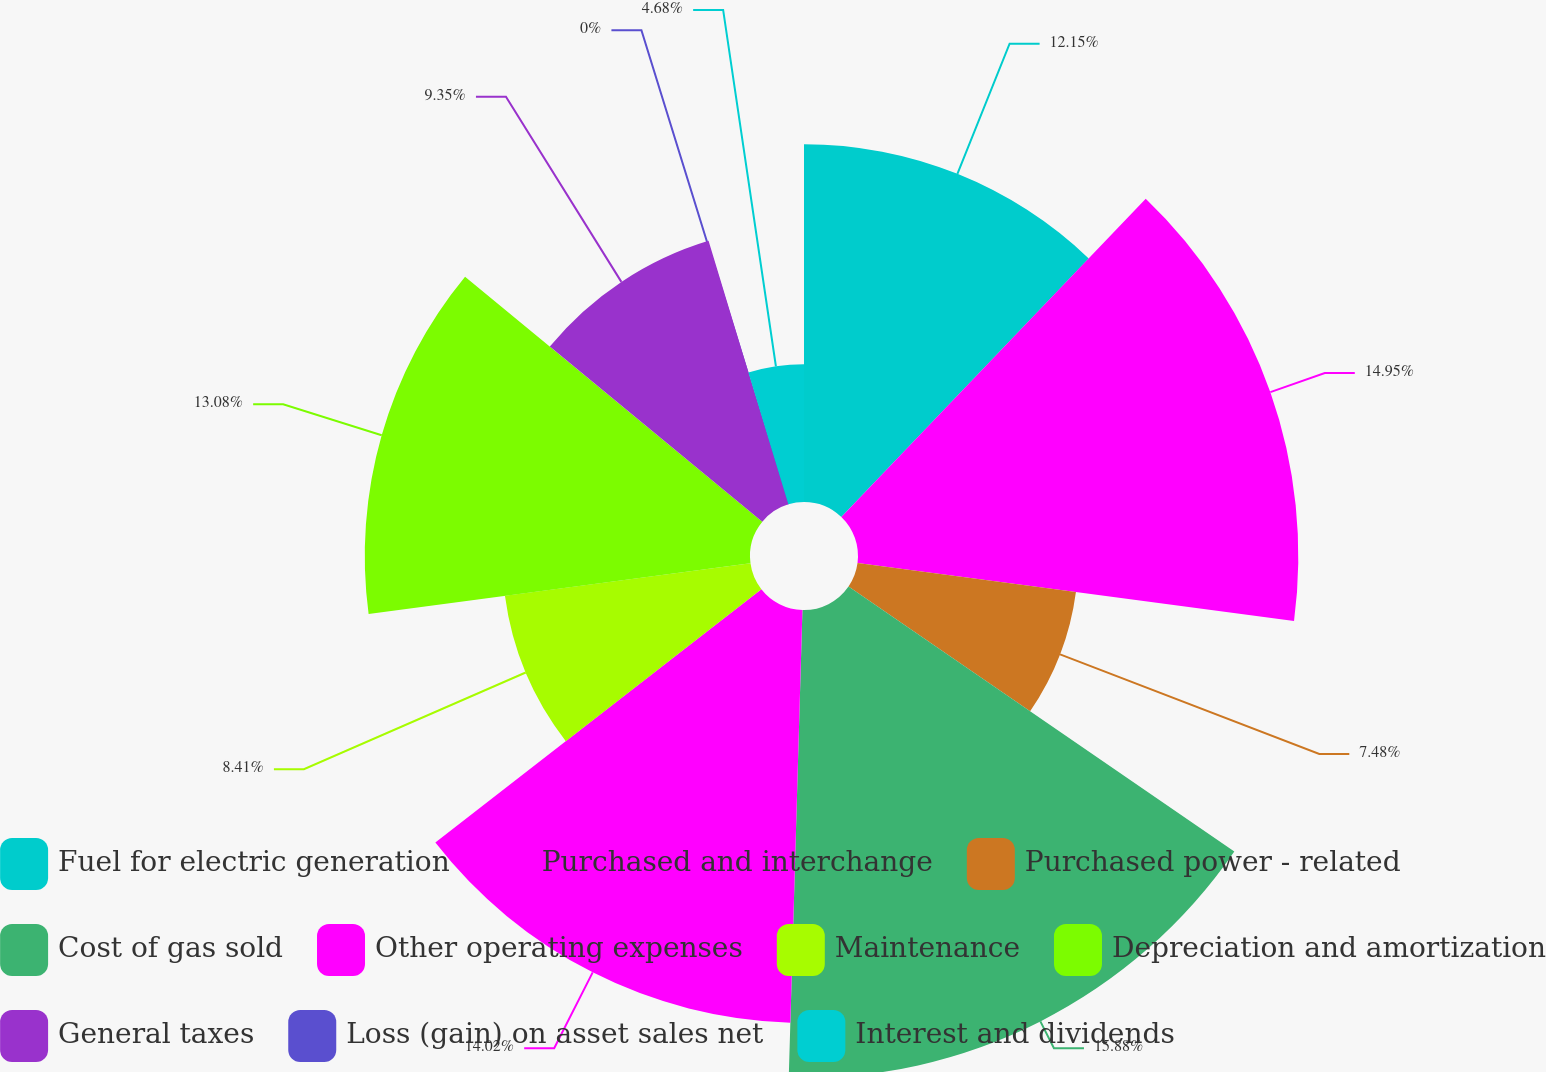Convert chart to OTSL. <chart><loc_0><loc_0><loc_500><loc_500><pie_chart><fcel>Fuel for electric generation<fcel>Purchased and interchange<fcel>Purchased power - related<fcel>Cost of gas sold<fcel>Other operating expenses<fcel>Maintenance<fcel>Depreciation and amortization<fcel>General taxes<fcel>Loss (gain) on asset sales net<fcel>Interest and dividends<nl><fcel>12.15%<fcel>14.95%<fcel>7.48%<fcel>15.89%<fcel>14.02%<fcel>8.41%<fcel>13.08%<fcel>9.35%<fcel>0.0%<fcel>4.68%<nl></chart> 